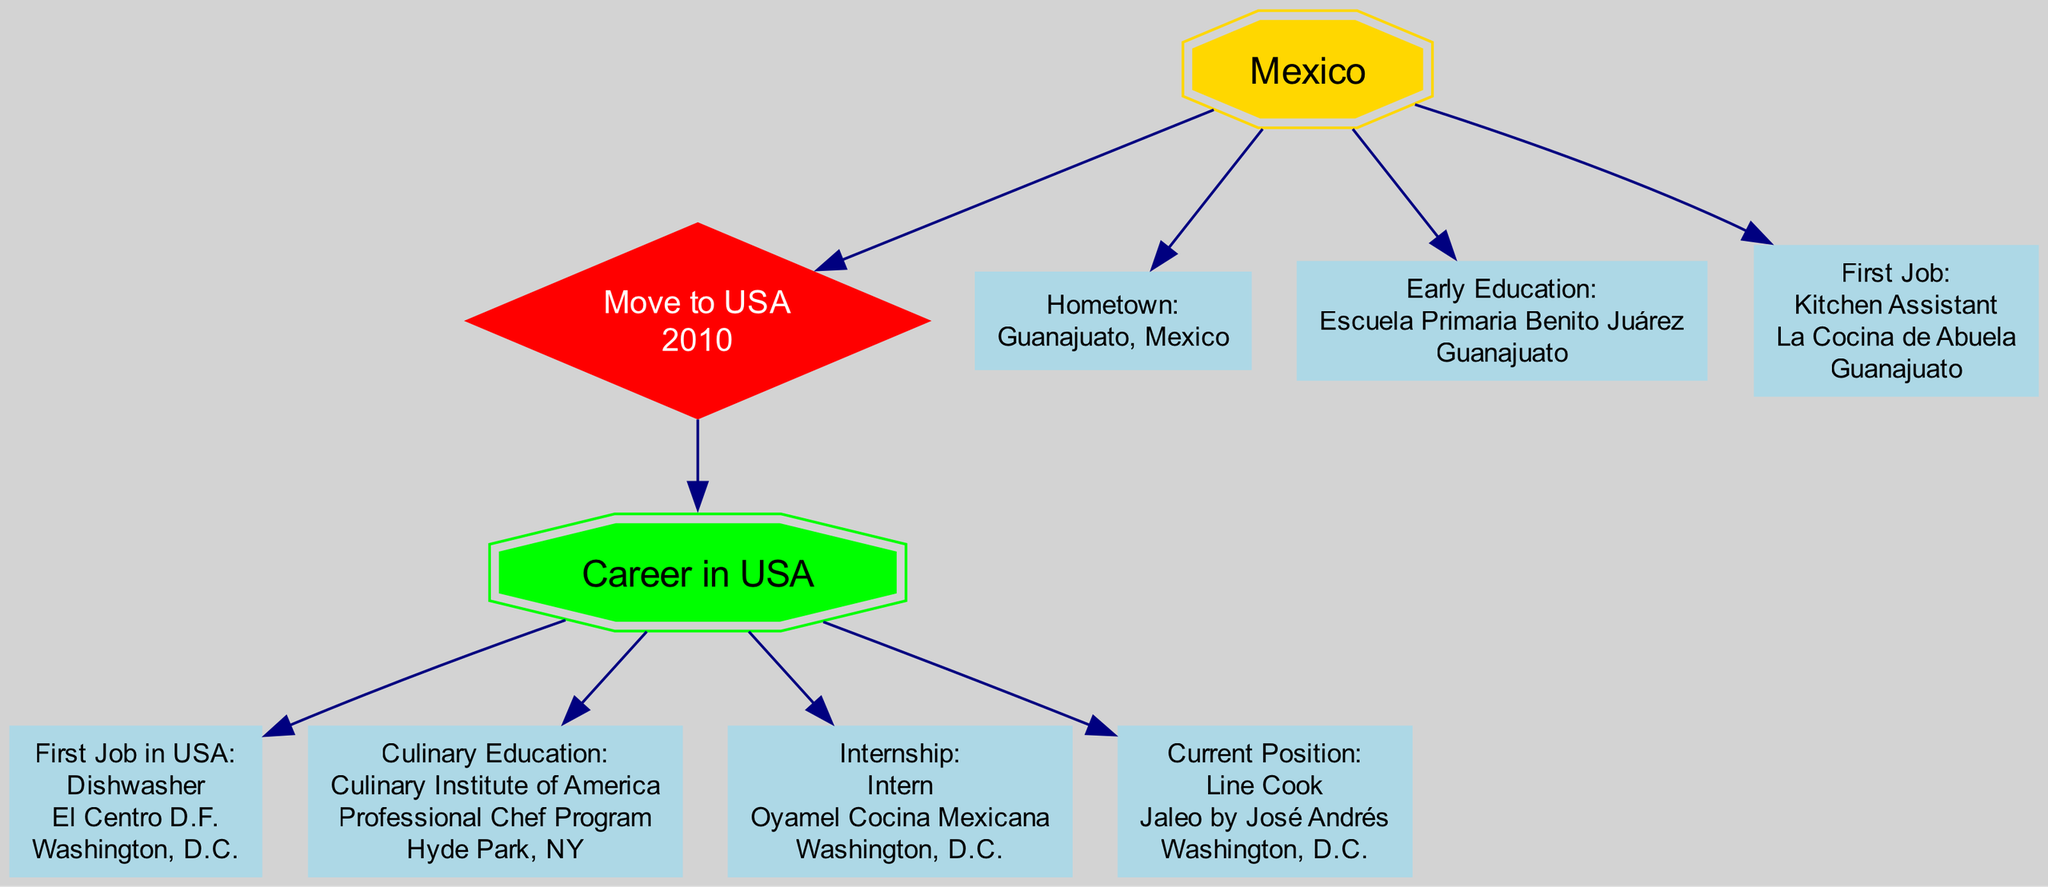What is the hometown listed in the diagram? The diagram specifies the hometown as part of the Mexico section under the "Hometown" node. It states the name "Guanajuato" along with the country "Mexico".
Answer: Guanajuato What was the first job in Mexico? According to the diagram, the first job listed under the "First Job" node in Mexico states the position as "Kitchen Assistant" at the restaurant "La Cocina de Abuela".
Answer: Kitchen Assistant In what year did the person move to the USA? The diagram clearly indicates the year of the move to the USA in the "Move to USA" node, which states it happened in "2010".
Answer: 2010 What was the first job in the USA? The "First Job in the USA" node of the Career in the USA section identifies the position as "Dishwasher" at the restaurant "El Centro D.F.".
Answer: Dishwasher What culinary school did the person attend in the USA? The "Culinary Education" node in the diagram specifies the school attended as "Culinary Institute of America", along with the certificate obtained, which is "Professional Chef Program".
Answer: Culinary Institute of America What is the current position in José Andrés' kitchen? The "Current Position" node in the Career in the USA section reveals that the current role is "Line Cook" at the restaurant "Jaleo by José Andrés".
Answer: Line Cook How many jobs are listed in the Career in the USA section? In the Career in the USA section, there are four distinct job-related nodes: "First Job in USA", "Culinary Education", "Internship", and "Current Position". Adding these gives a total of four jobs.
Answer: 4 What position did the person hold during their internship? The "Internship" node in the diagram details the position held as "Intern" at "Oyamel Cocina Mexicana".
Answer: Intern Which restaurant did the person work at as a Dishwasher? The diagram states under the "First Job in the USA" node that the restaurant where the person worked as a Dishwasher is "El Centro D.F.".
Answer: El Centro D.F 